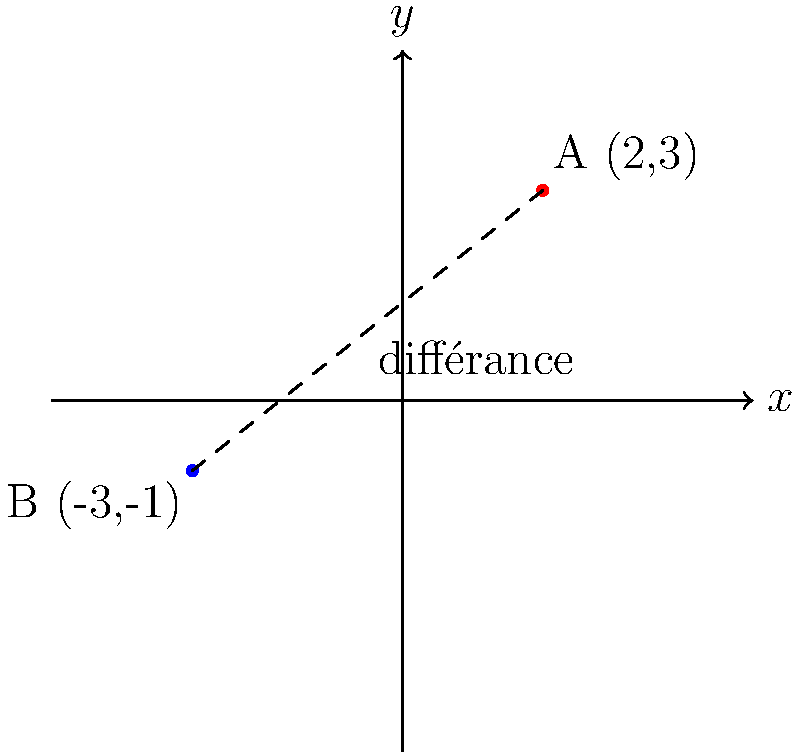In the coordinate plane above, points A(2,3) and B(-3,-1) are connected by a dashed line labeled "différance." How might this geometric representation relate to Derrida's concept of "différance," and what is the significance of the distance between these two points in the context of poststructuralist theory? To approach this question from a poststructuralist perspective:

1. Concept of "différance":
   Derrida's "différance" combines "difference" and "deferral," suggesting meaning is always in flux and never fully present.

2. Geometric representation:
   The line connecting points A and B can be seen as a visual metaphor for the space of "différance" between two signifiers or concepts.

3. Distance calculation:
   While we can calculate the distance using the formula $d = \sqrt{(x_2-x_1)^2 + (y_2-y_1)^2}$, the actual value is less important than its interpretation.

4. Interpretation of distance:
   The measurable distance represents the apparent gap between meanings, but this gap is always shifting and can never be fully bridged or defined.

5. Coordinates as signifiers:
   Points A(2,3) and B(-3,-1) can represent two concepts or signifiers in a system of language or thought.

6. Dashed line significance:
   The dashed line suggests the tenuous and constructed nature of the relationship between these points/concepts.

7. Poststructuralist implications:
   This representation challenges the idea of fixed meaning or binary oppositions, emphasizing the fluid and relational nature of signification.
Answer: The distance represents the space of "différance," illustrating the dynamic, unfixable nature of meaning in poststructuralist theory. 